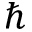<formula> <loc_0><loc_0><loc_500><loc_500>\hbar</formula> 